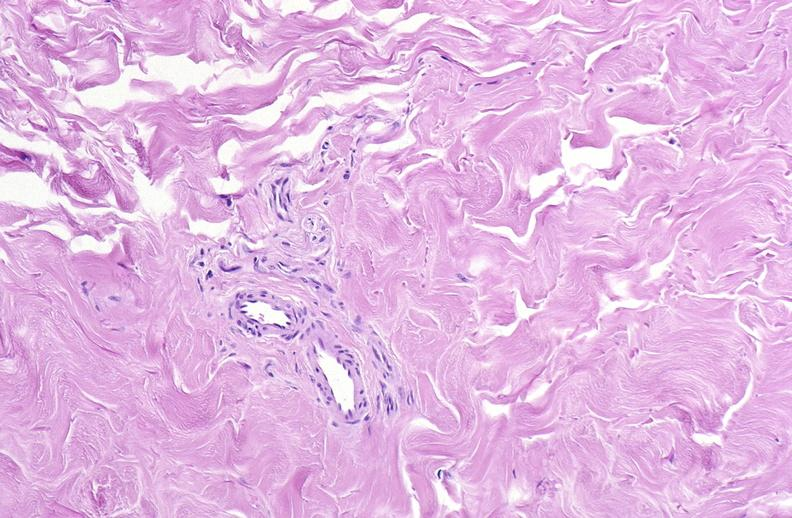does medial aspect show scleroderma?
Answer the question using a single word or phrase. No 